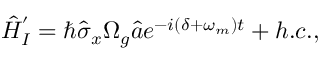Convert formula to latex. <formula><loc_0><loc_0><loc_500><loc_500>\begin{array} { r } { \hat { H } _ { I } ^ { ^ { \prime } } = \hbar { \hat } { \sigma } _ { x } \Omega _ { g } \hat { a } e ^ { - i ( \delta + \omega _ { m } ) t } + h . c . , } \end{array}</formula> 